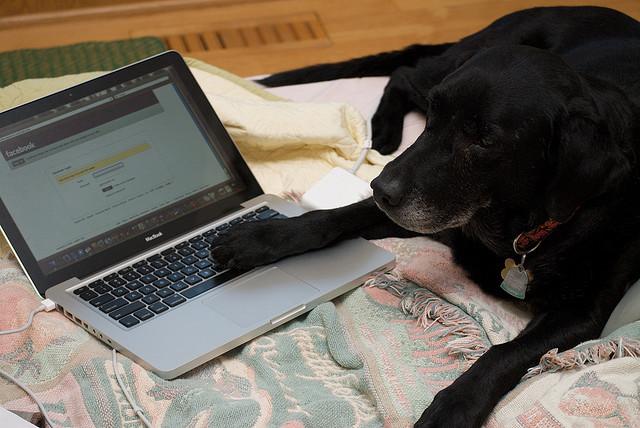Does this dog have a tag?
Give a very brief answer. Yes. What color is the dog?
Keep it brief. Black. What website is shown on the computer screen?
Concise answer only. Facebook. 